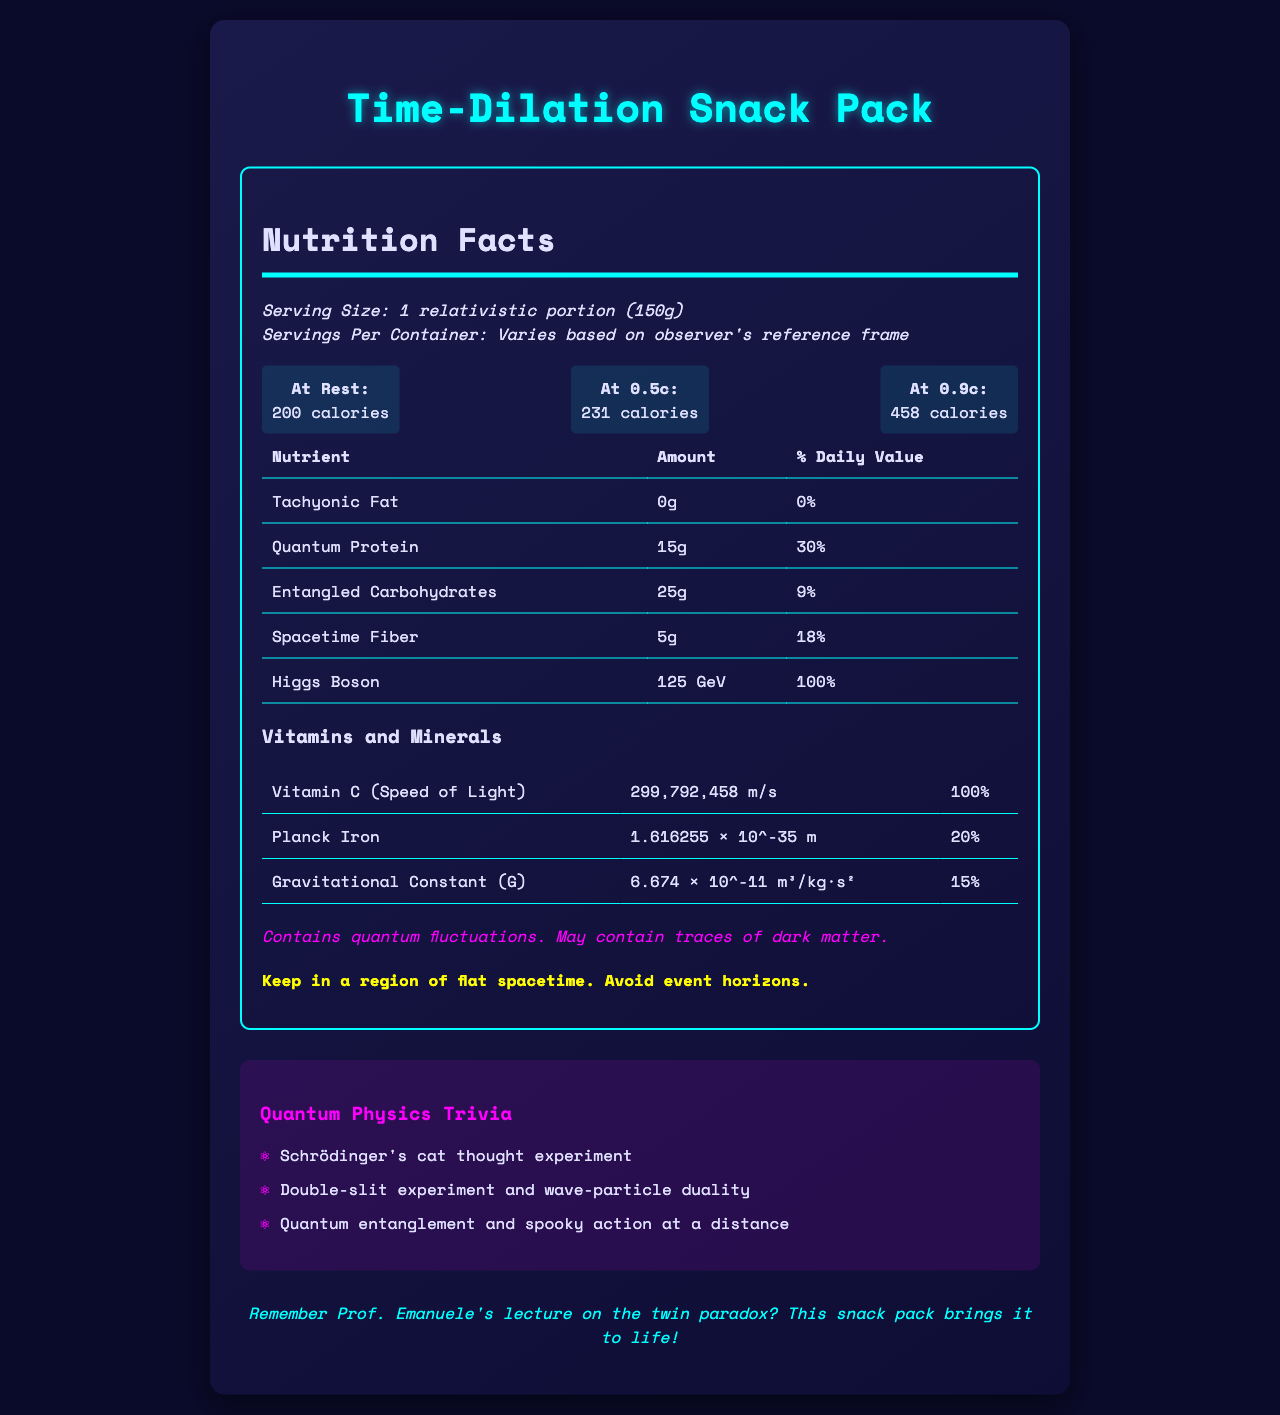What is the serving size of the Time-Dilation Snack Pack? The serving size is mentioned as "1 relativistic portion (150g)" in the document.
Answer: 1 relativistic portion (150g) How many calories does the Time-Dilation Snack Pack have at rest? The document lists the calories at rest as 200.
Answer: 200 calories What should you avoid when storing the Time-Dilation Snack Pack? The storage instructions clearly state to "Avoid event horizons."
Answer: Event horizons What is the daily value percentage of Quantum Protein? The daily value percentage of Quantum Protein is listed as 30%.
Answer: 30% What unique ingredient amount is listed as 125 GeV? The nutrient list shows that the Higgs Boson is listed as 125 GeV.
Answer: Higgs Boson How many calories does the Time-Dilation Snack Pack contain when traveling at 0.5c? The document states that the snack pack has 231 calories when traveling at 0.5c.
Answer: 231 calories Which nutrient has the highest daily value percentage? A. Quantum Protein B. Spacetime Fiber C. Higgs Boson The Higgs Boson has a daily value percentage of 100%, the highest listed.
Answer: C. Higgs Boson What is one potential application of the Time-Dilation Snack Pack? A. Weight loss B. Space travel nutrition C. Culinary arts One of the listed potential applications is "Space travel nutrition."
Answer: B. Space travel nutrition Is there Tachyonic Fat in the Time-Dilation Snack Pack? The document states that there is 0g of Tachyonic Fat.
Answer: No Explain the significance of time dilation as mentioned in the document. The document includes an infographic on time dilation, showing how velocity affects time dilation factors.
Answer: Time dilation effects are shown in a graph with the relationship between velocity and time dilation factors. For example, at 0.9c, the time dilation factor is 2.294, indicating time moves slower for someone traveling at this speed compared to someone at rest. Summarize the main idea of the document. The document provides a comprehensive breakdown of the Time-Dilation Snack Pack's nutritional content, along with relevant physics concepts and design choices inspired by these themes.
Answer: The document presents the nutritional information of a "Time-Dilation Snack Pack" with servings adjusted for relativistic effects, including unique nutrients like Quantum Protein and Higgs Boson. It highlights how the calories change at different velocities, provides storage instructions, lists allergen information, and includes infographics on spacetime curvature and time dilation, along with physics trivia and design elements. Does the Time-Dilation Snack Pack contain any dark matter? The allergen info states that it may contain traces of dark matter, but it is not confirmed.
Answer: Not enough information 